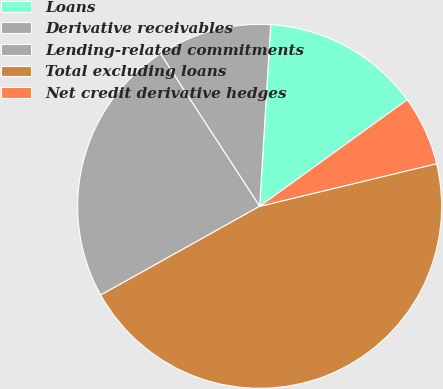<chart> <loc_0><loc_0><loc_500><loc_500><pie_chart><fcel>Loans<fcel>Derivative receivables<fcel>Lending-related commitments<fcel>Total excluding loans<fcel>Net credit derivative hedges<nl><fcel>14.08%<fcel>10.14%<fcel>23.93%<fcel>45.66%<fcel>6.19%<nl></chart> 